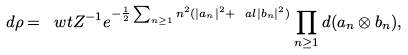Convert formula to latex. <formula><loc_0><loc_0><loc_500><loc_500>d \rho = \ w t { Z } ^ { - 1 } e ^ { - \frac { 1 } { 2 } \sum _ { n \geq 1 } n ^ { 2 } ( | a _ { n } | ^ { 2 } + \ a l | b _ { n } | ^ { 2 } ) } \prod _ { n \geq 1 } d ( a _ { n } \otimes b _ { n } ) ,</formula> 